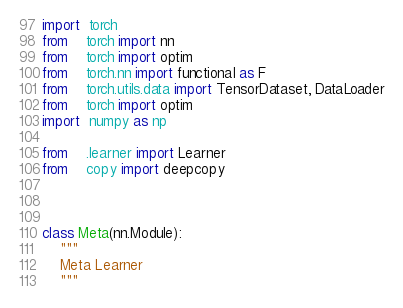Convert code to text. <code><loc_0><loc_0><loc_500><loc_500><_Python_>import  torch
from    torch import nn
from    torch import optim
from    torch.nn import functional as F
from    torch.utils.data import TensorDataset, DataLoader
from    torch import optim
import  numpy as np

from    .learner import Learner
from    copy import deepcopy



class Meta(nn.Module):
    """
    Meta Learner
    """</code> 